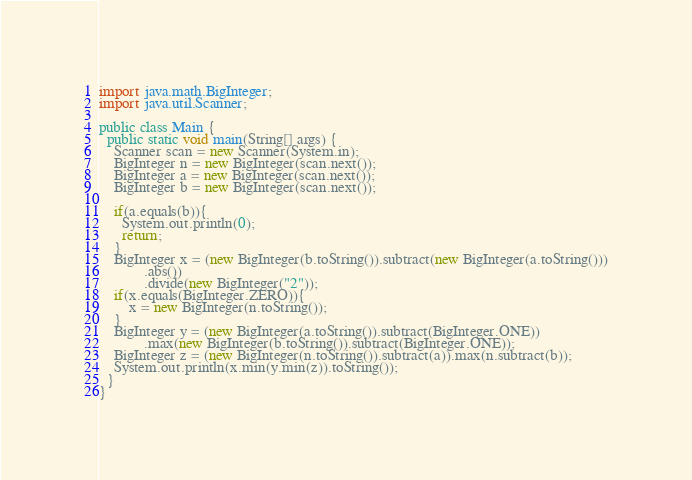<code> <loc_0><loc_0><loc_500><loc_500><_Java_>import java.math.BigInteger;
import java.util.Scanner;

public class Main {
  public static void main(String[] args) {
    Scanner scan = new Scanner(System.in);
    BigInteger n = new BigInteger(scan.next());
    BigInteger a = new BigInteger(scan.next());
    BigInteger b = new BigInteger(scan.next());

    if(a.equals(b)){
      System.out.println(0);
      return;
    }
    BigInteger x = (new BigInteger(b.toString()).subtract(new BigInteger(a.toString()))
            .abs())
            .divide(new BigInteger("2"));
    if(x.equals(BigInteger.ZERO)){
        x = new BigInteger(n.toString());
    }
    BigInteger y = (new BigInteger(a.toString()).subtract(BigInteger.ONE))
            .max(new BigInteger(b.toString()).subtract(BigInteger.ONE));
    BigInteger z = (new BigInteger(n.toString()).subtract(a)).max(n.subtract(b));
    System.out.println(x.min(y.min(z)).toString());
  }
}
</code> 